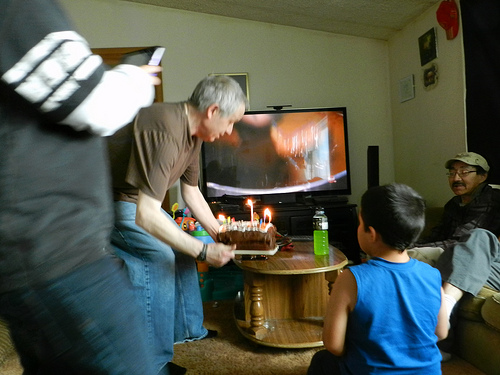How many people are wearing glasses in this image? 1 